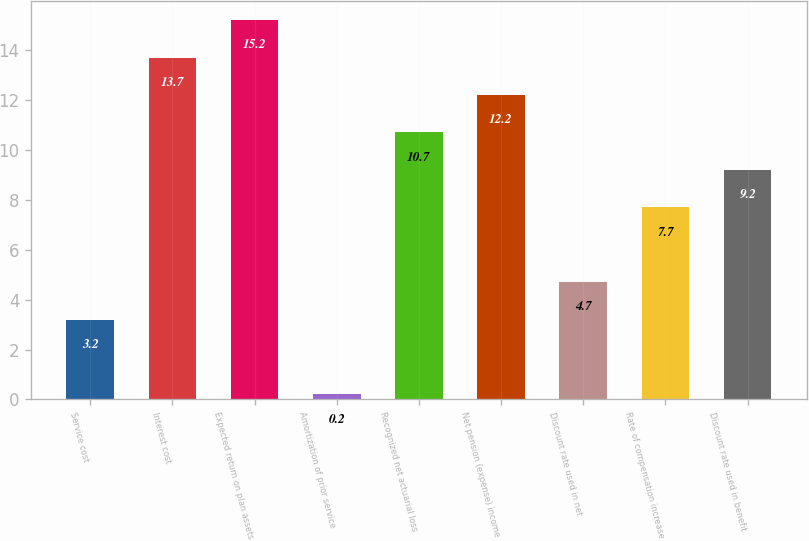Convert chart. <chart><loc_0><loc_0><loc_500><loc_500><bar_chart><fcel>Service cost<fcel>Interest cost<fcel>Expected return on plan assets<fcel>Amortization of prior service<fcel>Recognized net actuarial loss<fcel>Net pension (expense) income<fcel>Discount rate used in net<fcel>Rate of compensation increase<fcel>Discount rate used in benefit<nl><fcel>3.2<fcel>13.7<fcel>15.2<fcel>0.2<fcel>10.7<fcel>12.2<fcel>4.7<fcel>7.7<fcel>9.2<nl></chart> 